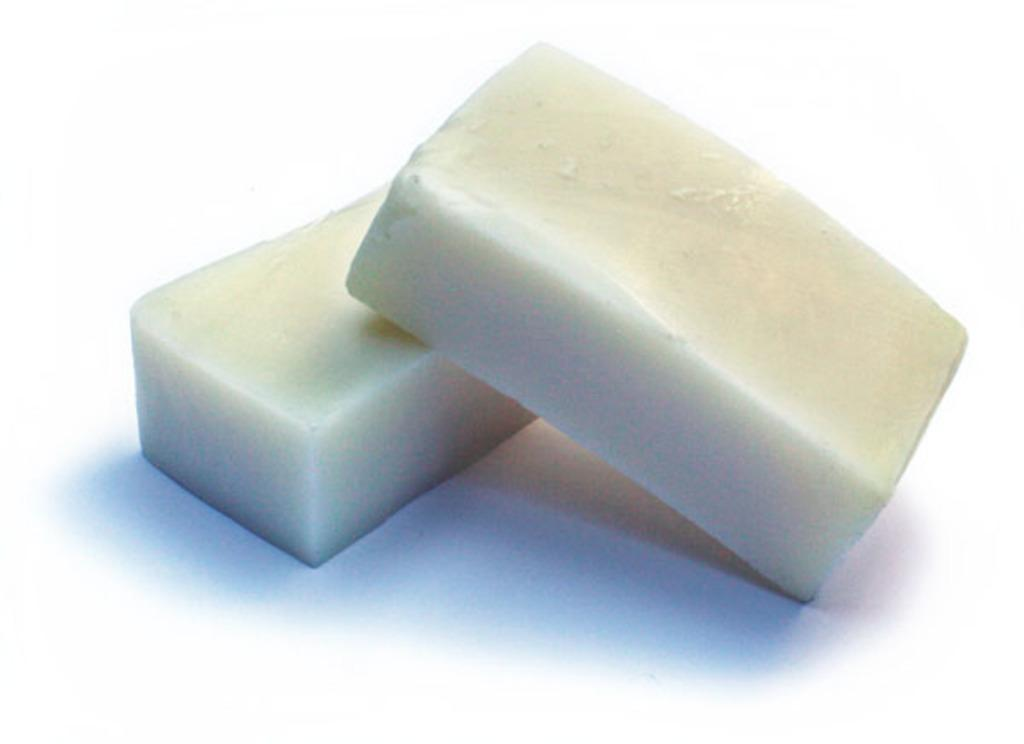What color are the objects in the image? The objects in the image are white. Can you see a tub filled with markers in the image? There is no tub or markers present in the image. 